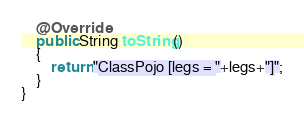<code> <loc_0><loc_0><loc_500><loc_500><_Java_>    @Override
    public String toString()
    {
        return "ClassPojo [legs = "+legs+"]";
    }
}
</code> 